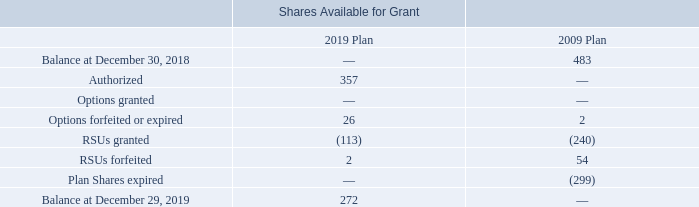Stock-Based Compensation Award Activity
The following table summarizes the shares available for grant under the 2019 Plan and 2009 Plan (in thousands):
What are the respective number of options forfeited or expired in the 2019 and 2009 plans?
Answer scale should be: thousand. 26, 2. What are the respective number of RSUs granted in the 2019 and 2009 plans?
Answer scale should be: thousand. 113, 240. What are the respective number of RSUs forfeited in the 2019 and 2009 plans?
Answer scale should be: thousand. 2, 54. What is the percentage change in the number of options forfeited or expired between the 2019 and 2009 plans?
Answer scale should be: percent. (26 - 2)/2 
Answer: 1200. What is the percentage change in the number of RSUs granted between the 2019 and 2009 plans?
Answer scale should be: percent. (113 - 240)/240 
Answer: -52.92. What is the percentage change in the number of RSUs forfeited between the 2019 and 2009 plans?
Answer scale should be: percent. (2 - 54)/54  
Answer: -96.3. 